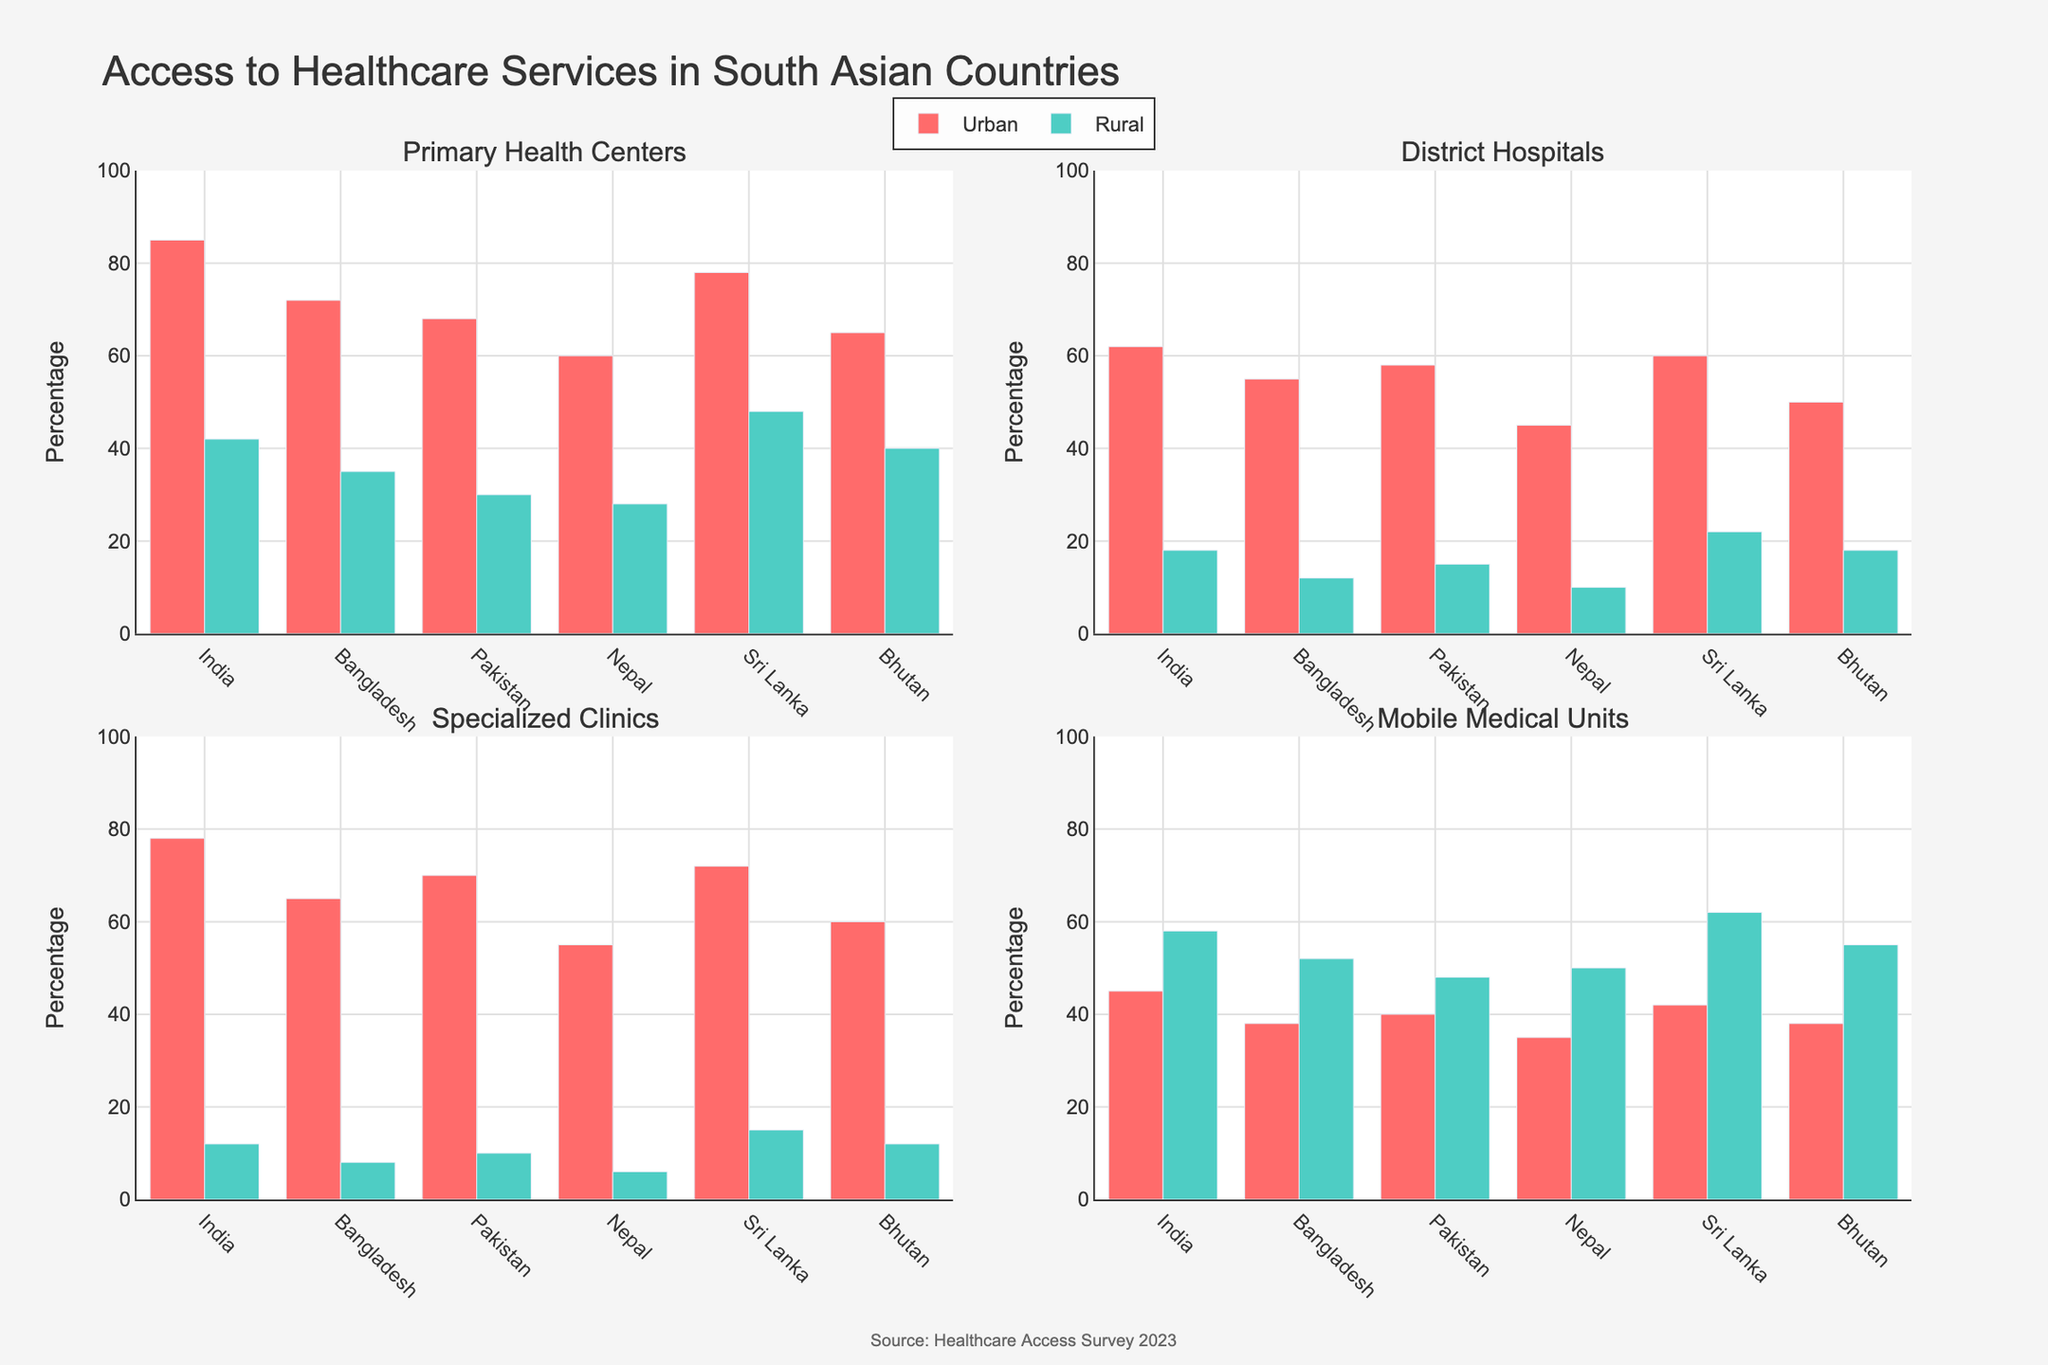What is the title of the figure? The title of the figure is found at the top center. By reading, we find that it shows the "Voter Turnout Rates in Presidential Elections by State (2004-2020)".
Answer: Voter Turnout Rates in Presidential Elections by State (2004-2020) Which state had the highest voter turnout in 2020? By looking at the subplots, specifically the point for the year 2020, we observe that Minnesota had the highest voter turnout rate, marked close to 80%.
Answer: Minnesota What is the range of voter turnout rates for Texas from 2004 to 2020? From Texas's subplot, we locate the highest and lowest voter turnout rates. The highest is 60.4% (2020) and the lowest is 51.4% (2016). The range can be calculated as 60.4 - 51.4.
Answer: 9.0% Did Wisconsin experience an increase or decrease in voter turnout from 2016 to 2020? By comparing the voter turnout in Wisconsin for the years 2016 (approximately 67.3%) and 2020 (roughly 75.8%), we see that the voter turnout increased.
Answer: Increase How many states have a voter turnout rate that exceeded 70% in the 2020 election cycle? Inspecting each subplot for the year 2020, we notice that Minnesota, Pennsylvania, Wisconsin, North Carolina, and Michigan had voter turnout rates above 70%. Counting these states gives us the answer.
Answer: 5 Compare and name the states where voter turnout rates increased consecutively across the last three election cycles (2012, 2016, 2020). We need to identify states where the plot points for 2012, 2016, and 2020 demonstrate a consistent upward trend. We find that Pennsylvania and Michigan are the states with such a consecutive increase in voter turnout rates.
Answer: Pennsylvania, Michigan Which state had the most significant drop in voter turnout between two consecutive election cycles? By looking for the steepest drop between two points in any subplot, we find that Florida had the most significant drop between 2012 and 2016, from approximately 72.0% to nearly 65.7%.
Answer: Florida What is the median voter turnout rate for Georgia across the 5 election cycles? We list Georgia's voter turnout rates: 56.2%, 62.5%, 59.0%, 59.8%, 67.7%. Ordering these values (56.2%, 59.0%, 59.8%, 62.5%, 67.7%), the median value is the middle one, which is 59.8%.
Answer: 59.8% Which state shows the smallest variability in voter turnout rates over the 5 election cycles? We calculate and compare the variance in voter turnout rates for each state. Minnesota has turnout rates that are very close to each other (ranging from 74.8% to 79.9%) suggesting minimal variability.
Answer: Minnesota 